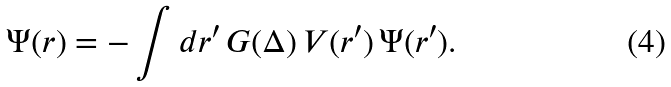Convert formula to latex. <formula><loc_0><loc_0><loc_500><loc_500>\Psi ( { r } ) = - \int d { r } ^ { \prime } \, G ( \Delta ) \, V ( { r } ^ { \prime } ) \, \Psi ( { r } ^ { \prime } ) .</formula> 